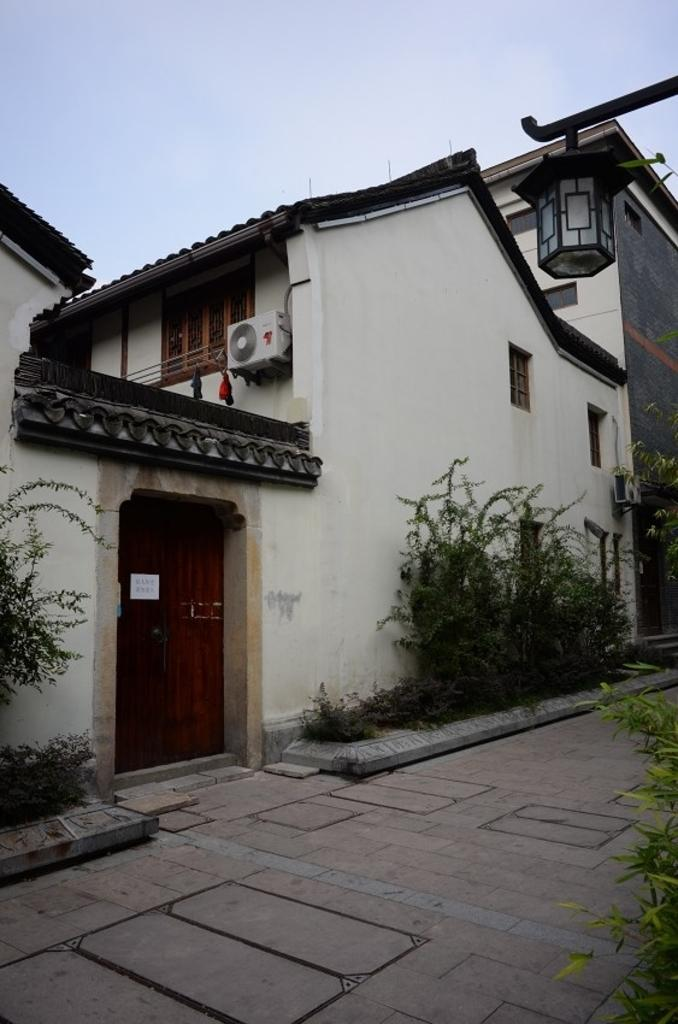What can be seen in the sky in the image? The sky is visible in the image. What type of structure is present in the image? There is a building in the image. What features can be observed on the building? The building has windows and a door. Is there any source of illumination in the image? Yes, there is a light in the image. What type of vegetation is present in the image? There are plants in the image. What type of cooling system is visible in the image? There are air conditioners in the image. What type of pathway is present at the bottom portion of the image? There is a pathway at the bottom portion of the image. What language are the birds speaking as they flock together in the image? There are no birds present in the image, so it is not possible to determine what language they might be speaking. 